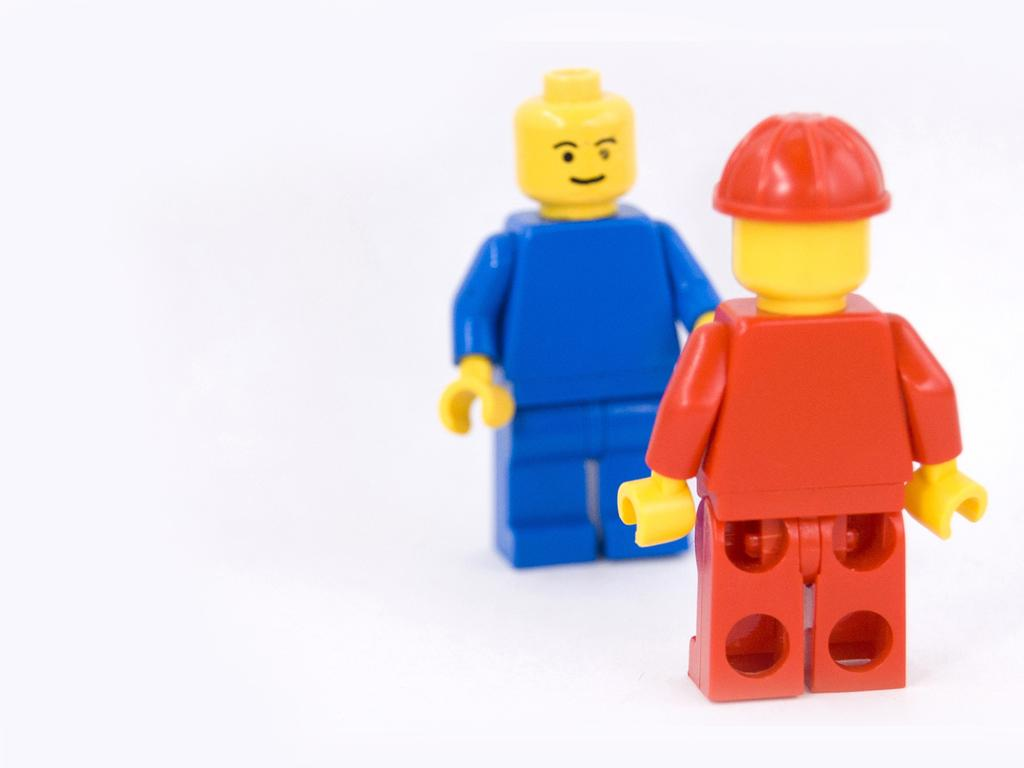What color is the background of the image? The background of the image is white. Where are the toys located in the image? The toys are on the right side of the image. What colors are the toys? The toys are red and blue in color. Can you see any quicksand in the image? There is no quicksand present in the image. What type of bag is being used to carry the toys in the image? There is no bag visible in the image, as the toys are simply placed on the right side. 